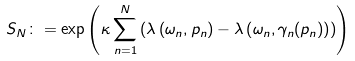<formula> <loc_0><loc_0><loc_500><loc_500>S _ { N } \colon = \exp \left ( \kappa \sum _ { n = 1 } ^ { N } \left ( \lambda \left ( \omega _ { n } , p _ { n } \right ) - \lambda \left ( \omega _ { n } , \gamma _ { n } ( p _ { n } ) \right ) \right ) \right )</formula> 